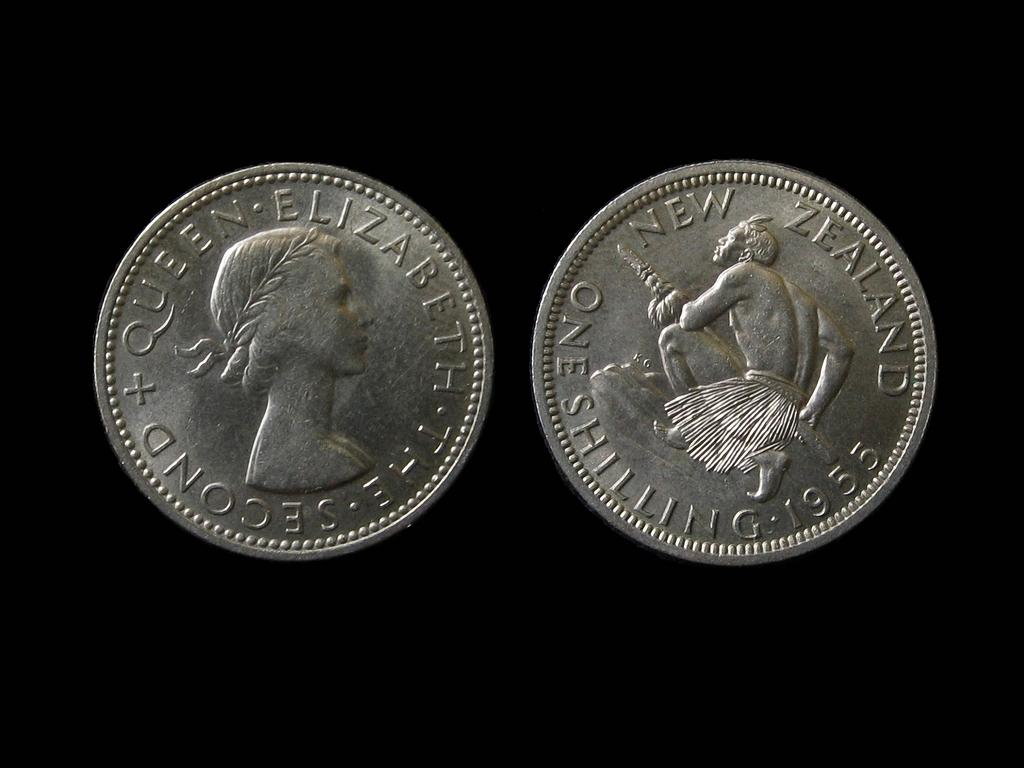<image>
Share a concise interpretation of the image provided. The front and back image of a 1955 Shilling from New Zealand. 